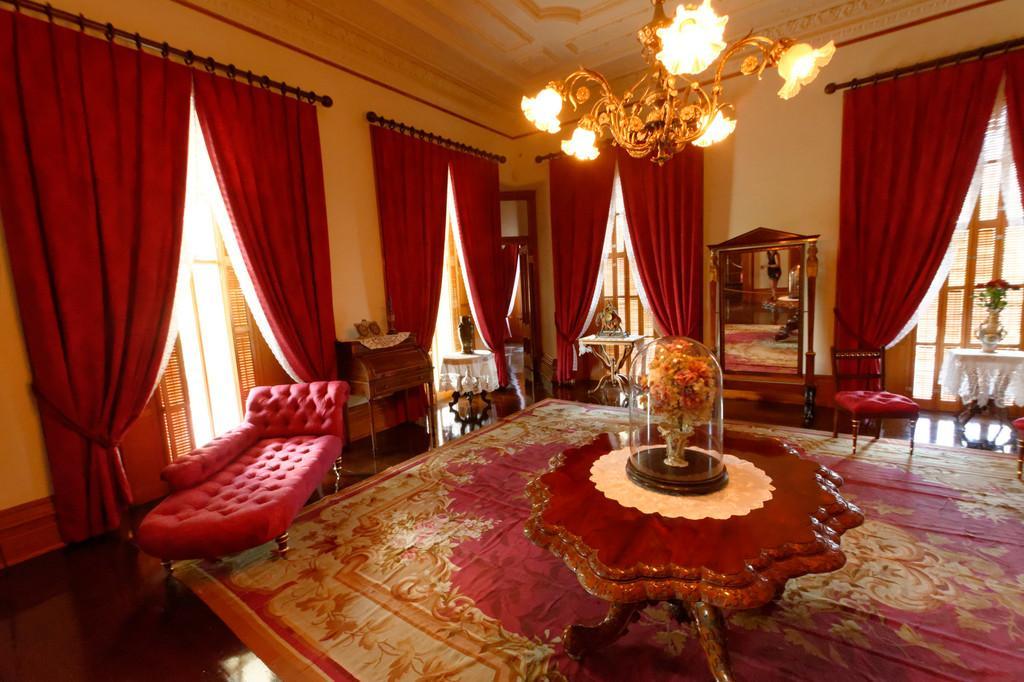Describe this image in one or two sentences. In this picture there is a sofa, table on which a bouquet was placed. There is a carpet on the floor. There is a chair here. A mirror beside the chair. A chandelier is hanging from the ceiling. And there are some curtains here. In the background there is a wall. 